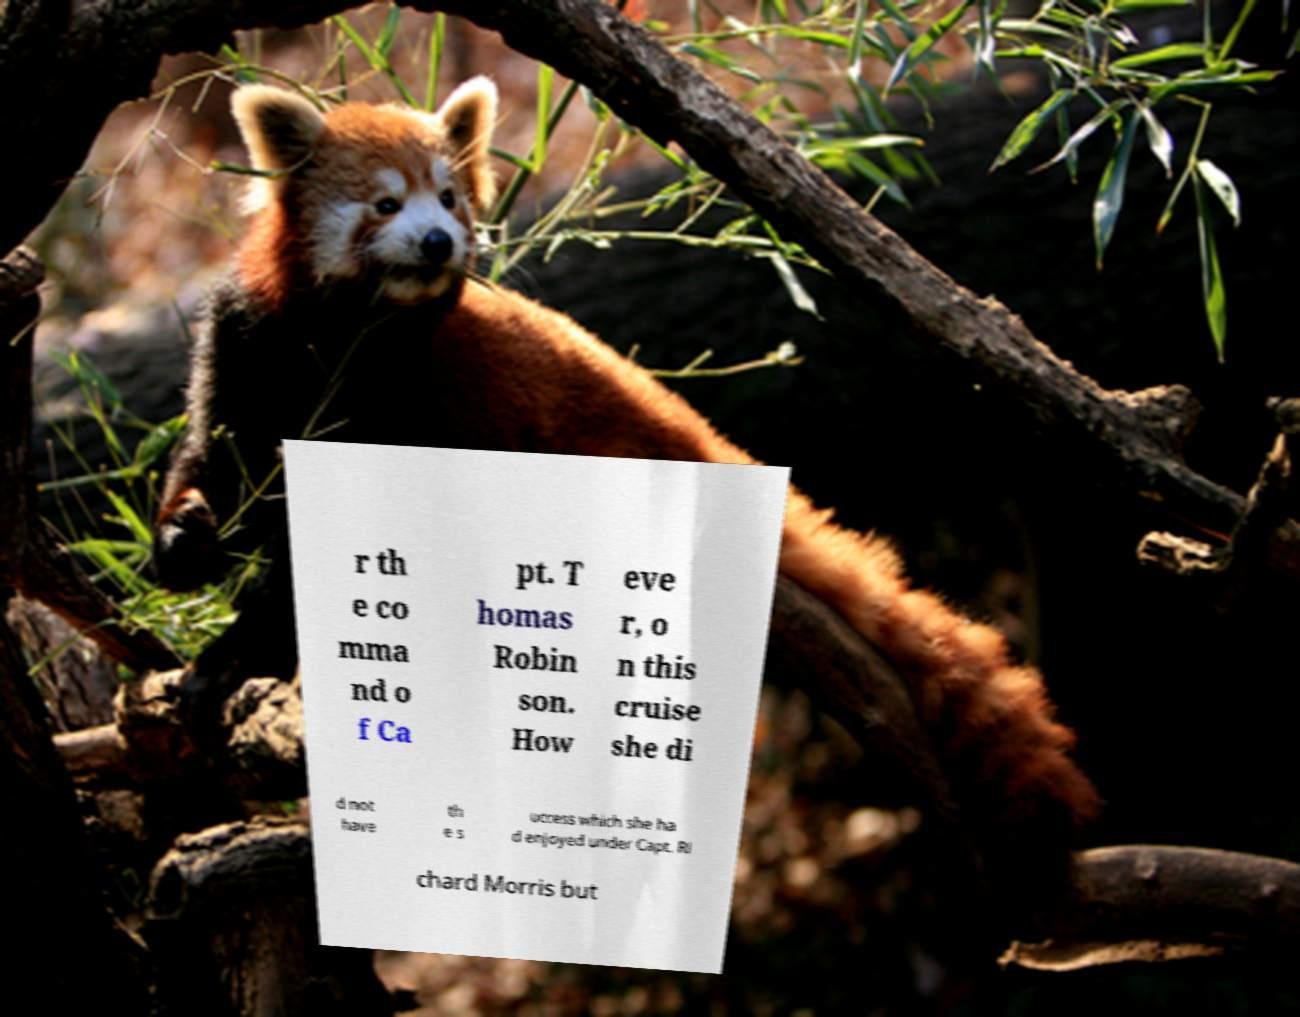Please read and relay the text visible in this image. What does it say? r th e co mma nd o f Ca pt. T homas Robin son. How eve r, o n this cruise she di d not have th e s uccess which she ha d enjoyed under Capt. Ri chard Morris but 